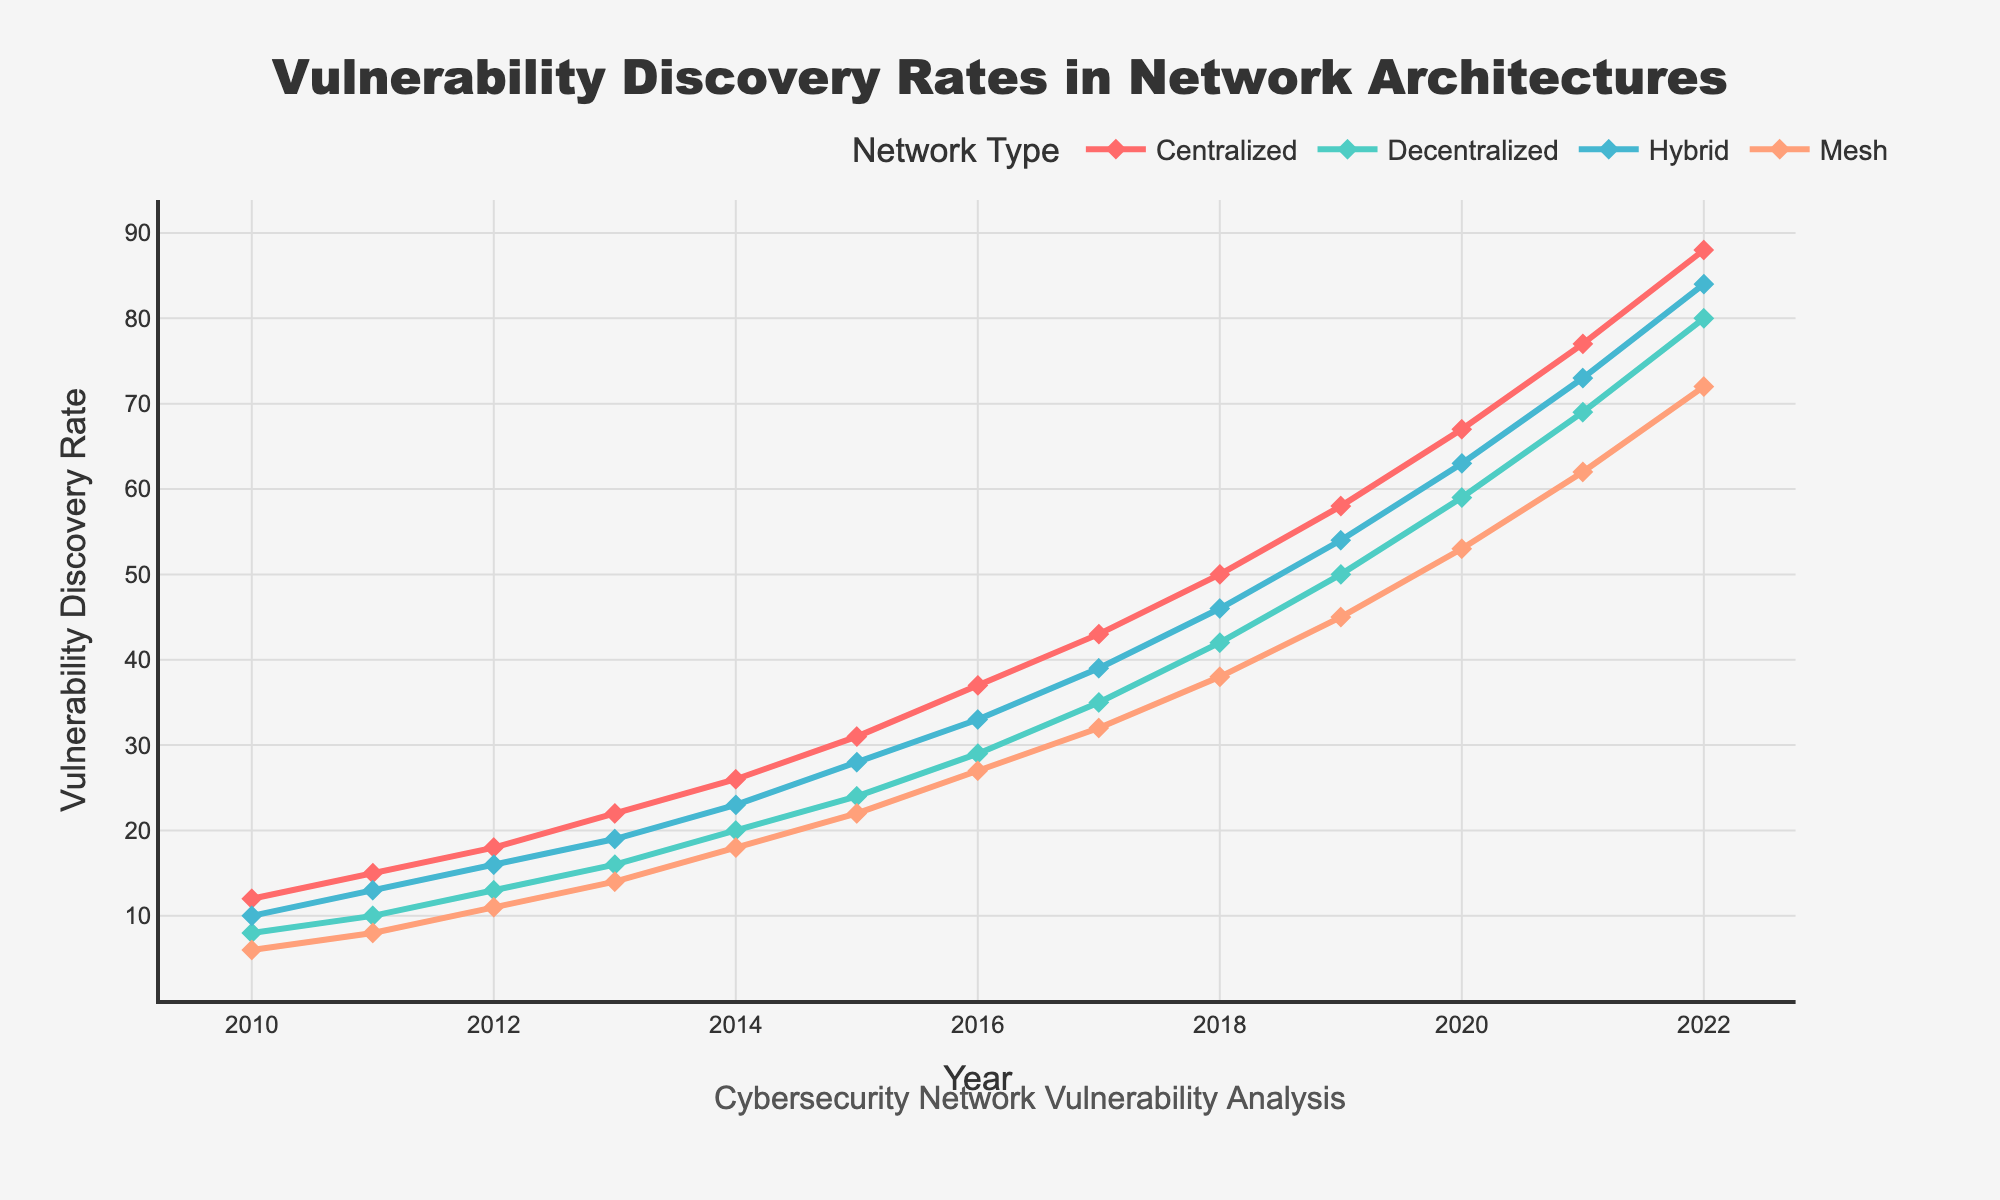What year saw the highest vulnerability discovery rate in the Centralized network? From the chart, the vulnerability discovery rate for the Centralized network consistently increases. The highest value is at the end of the given time period. The highest rate for the Centralized network is in 2022.
Answer: 2022 Which network type had the lowest vulnerability discovery rate in 2015? From the chart, in 2015, the vulnerability discovery rates for each network type are as follows: Centralized = 31, Decentralized = 24, Hybrid = 28, Mesh = 22. The lowest value among these is for the Mesh network.
Answer: Mesh What is the increase in vulnerability discovery rate for the Decentralized network from 2010 to 2022? The vulnerability discovery rate for the Decentralized network in 2010 is 8 and in 2022 is 80. The increase is calculated as 80 - 8.
Answer: 72 In which period did the Hybrid network see the most significant increase in vulnerability discovery rate? Observing the slopes of the lines for the Hybrid network, the most significant increase occurred between 2021 and 2022 where the rate increased from 73 to 84.
Answer: 2021 to 2022 How much higher is the vulnerability discovery rate for the Mesh network in 2022 compared to 2015? The vulnerability discovery rate for the Mesh network in 2022 is 72, and in 2015 it is 22. The difference is 72 - 22.
Answer: 50 Between which two years did the Centralized network see the least increase in vulnerability discovery rate? By examining the slope of the line for the Centralized network, the smallest increase occurred between 2010 and 2011, where the rate increased from 12 to 15.
Answer: 2010 and 2011 Compared to the Decentralized network, how much higher was the vulnerability discovery rate for the Centralized network in 2018? In 2018, the vulnerability discovery rates are: Centralized = 50 and Decentralized = 42. The difference is 50 - 42.
Answer: 8 What was the average annual increase in vulnerability discovery rate for the Mesh network from 2010 to 2022? The vulnerability discovery rate for the Mesh network increased from 6 in 2010 to 72 in 2022. The period span is 2022 - 2010 = 12 years. The increase is 72 - 6 = 66. The average annual increase is 66 / 12.
Answer: 5.5 Which network type had the most consistent yearly increase in vulnerability discovery rates? By observing the slopes of the lines, the Decentralized network appears to have the most consistent (linear) increase over the years.
Answer: Decentralized How does the vulnerability discovery rate of the Hybrid network in 2016 compare to that of the Mesh network in 2022? The vulnerability discovery rate for the Hybrid network in 2016 is 33, and for the Mesh network in 2022, it is 72. The Mesh network's rate in 2022 is significantly higher.
Answer: Mesh network rates are higher in 2022 